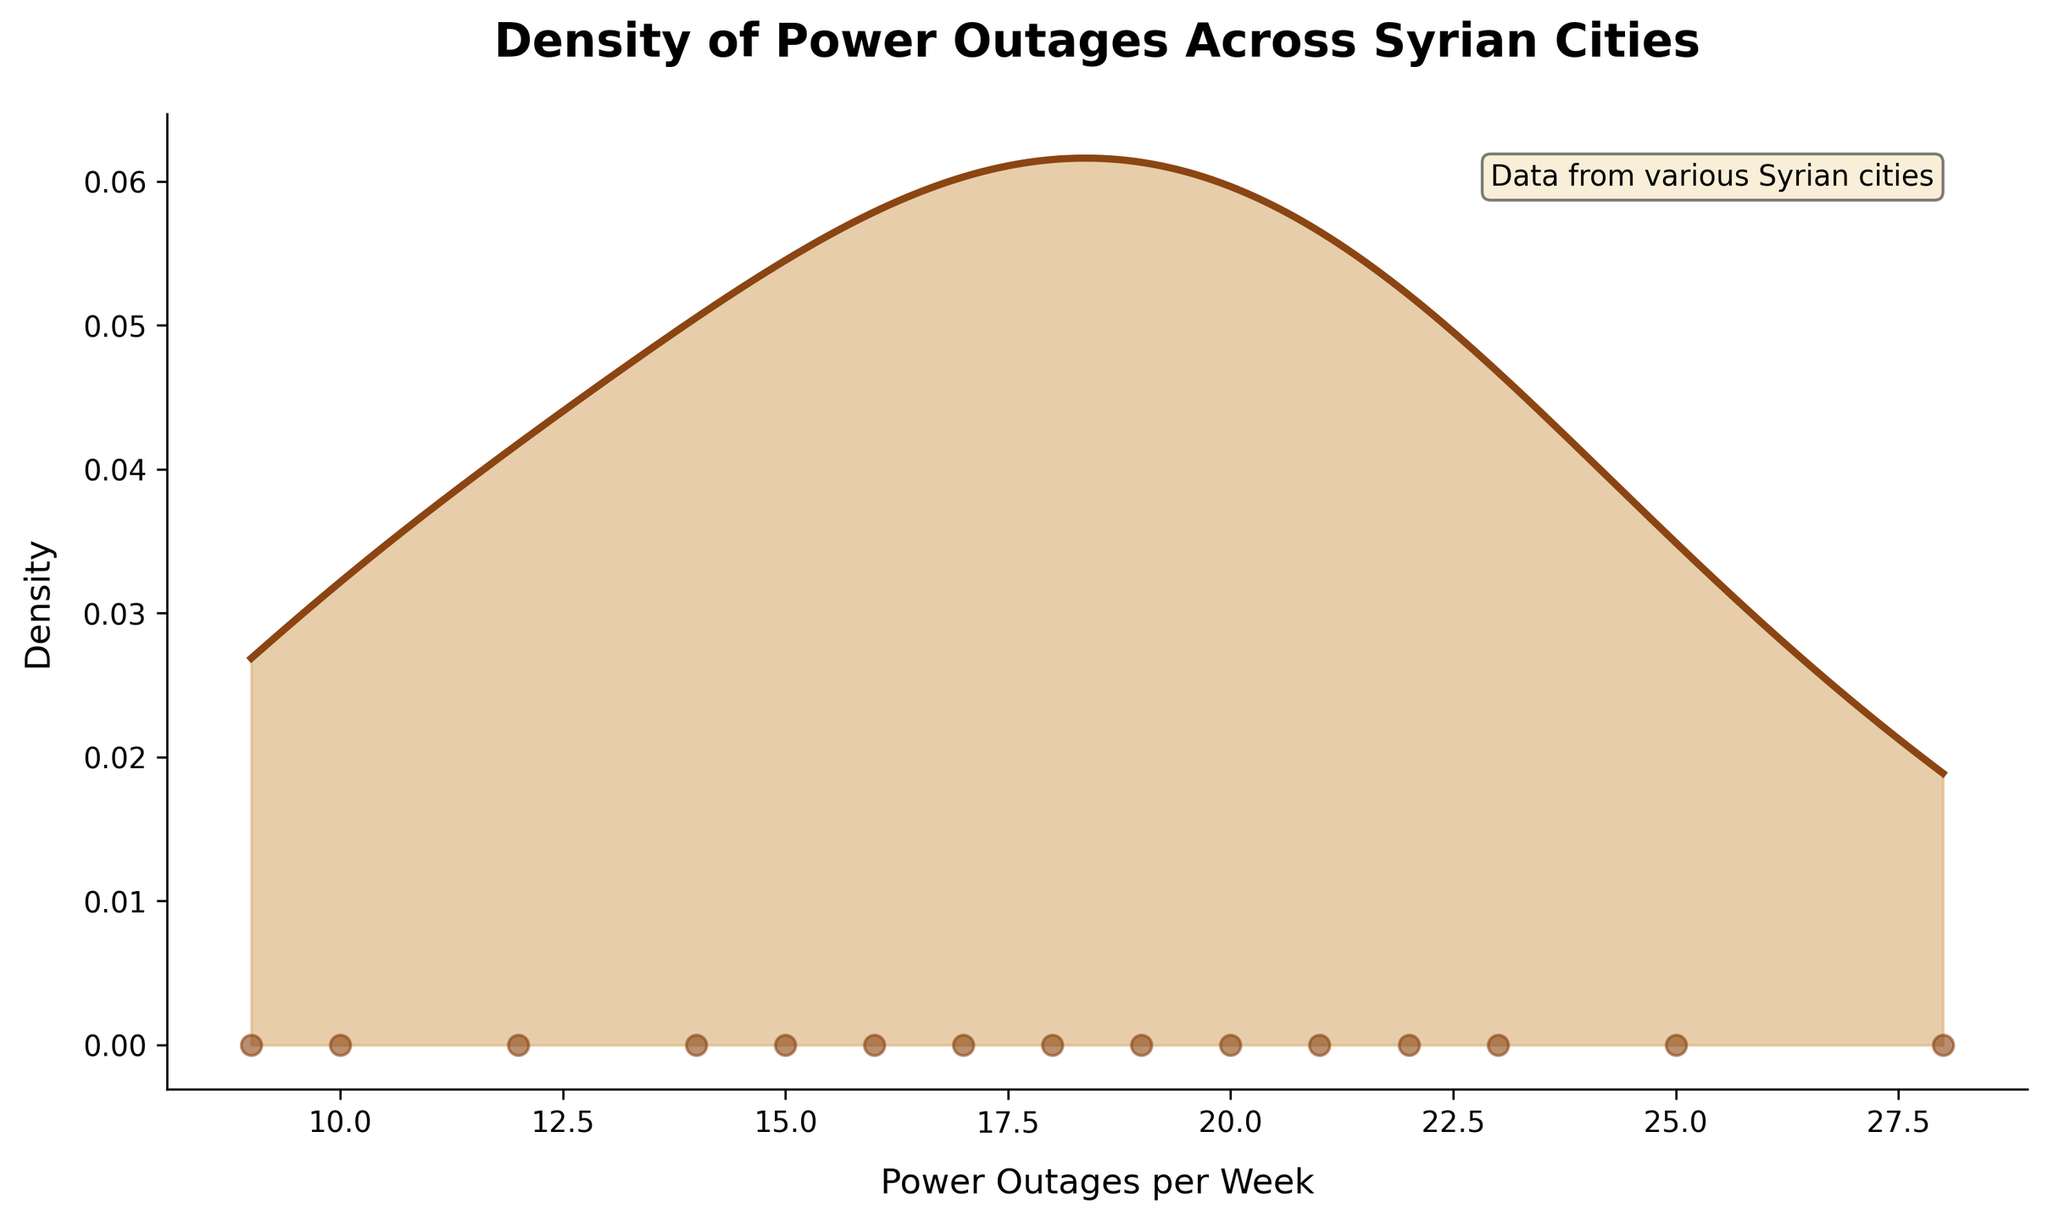What is the title of the plot? The title is shown at the top of the plot. It summarizes the subject of the figure.
Answer: Density of Power Outages Across Syrian Cities How is the x-axis labeled? The x-axis represents the variable being measured, and its label is situated below the axis.
Answer: Power Outages per Week How many cities had their power outages per week recorded? The number of data points on the scatter plot, each representing a different city, indicates the number of cities. Counting these points will give us the answer.
Answer: 15 What is the approximate range of power outages per week? Observing the scatter plot points and the x-axis labels gives us the minimum and maximum values of power outages.
Answer: 9 to 28 Which city experienced the highest number of power outages per week? By checking the scatter plot points and finding the one located farthest to the right on the x-axis, we can determine which city had the maximum outages.
Answer: Raqqa Which city experienced the lowest number of power outages per week? By checking the scatter plot points and finding the one located farthest to the left on the x-axis, we can determine which city had the minimum outages.
Answer: Tartus What does the area under the curve represent? The filled area under the curve in a density plot shows the probability distribution of the variable across the measured points.
Answer: Distribution of power outages How do you identify the cities with the most frequent power outages using the density curve? The peak of the density curve indicates the region where the largest concentration of data points lies. Points near this peak show cities with frequent power outages.
Answer: Near the peak of the density curve Which two cities' outage frequencies might be closest together? By locating and comparing the scatter plot points on the x-axis that are closest to each other, we can identify which cities have the closest outage frequencies.
Answer: Hama and Homs How would you describe the skewness of the density curve? Observing the shape of the density curve, if it leans more to one side than the other, determines whether the distribution is skewed. If the longer tail is on the right, it’s positively skewed; if on the left, it’s negatively skewed.
Answer: Positively skewed 